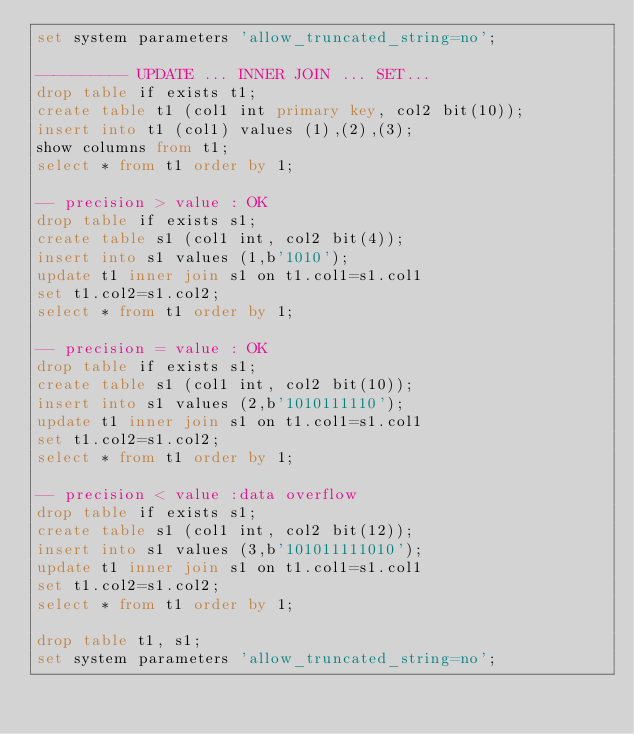<code> <loc_0><loc_0><loc_500><loc_500><_SQL_>set system parameters 'allow_truncated_string=no';

---------- UPDATE ... INNER JOIN ... SET...
drop table if exists t1;
create table t1 (col1 int primary key, col2 bit(10));
insert into t1 (col1) values (1),(2),(3);
show columns from t1;
select * from t1 order by 1;

-- precision > value : OK
drop table if exists s1;
create table s1 (col1 int, col2 bit(4));
insert into s1 values (1,b'1010');
update t1 inner join s1 on t1.col1=s1.col1
set t1.col2=s1.col2;
select * from t1 order by 1;

-- precision = value : OK
drop table if exists s1;
create table s1 (col1 int, col2 bit(10));
insert into s1 values (2,b'1010111110');
update t1 inner join s1 on t1.col1=s1.col1
set t1.col2=s1.col2;
select * from t1 order by 1;

-- precision < value :data overflow
drop table if exists s1;
create table s1 (col1 int, col2 bit(12));
insert into s1 values (3,b'101011111010');
update t1 inner join s1 on t1.col1=s1.col1
set t1.col2=s1.col2;
select * from t1 order by 1;

drop table t1, s1;
set system parameters 'allow_truncated_string=no';
</code> 